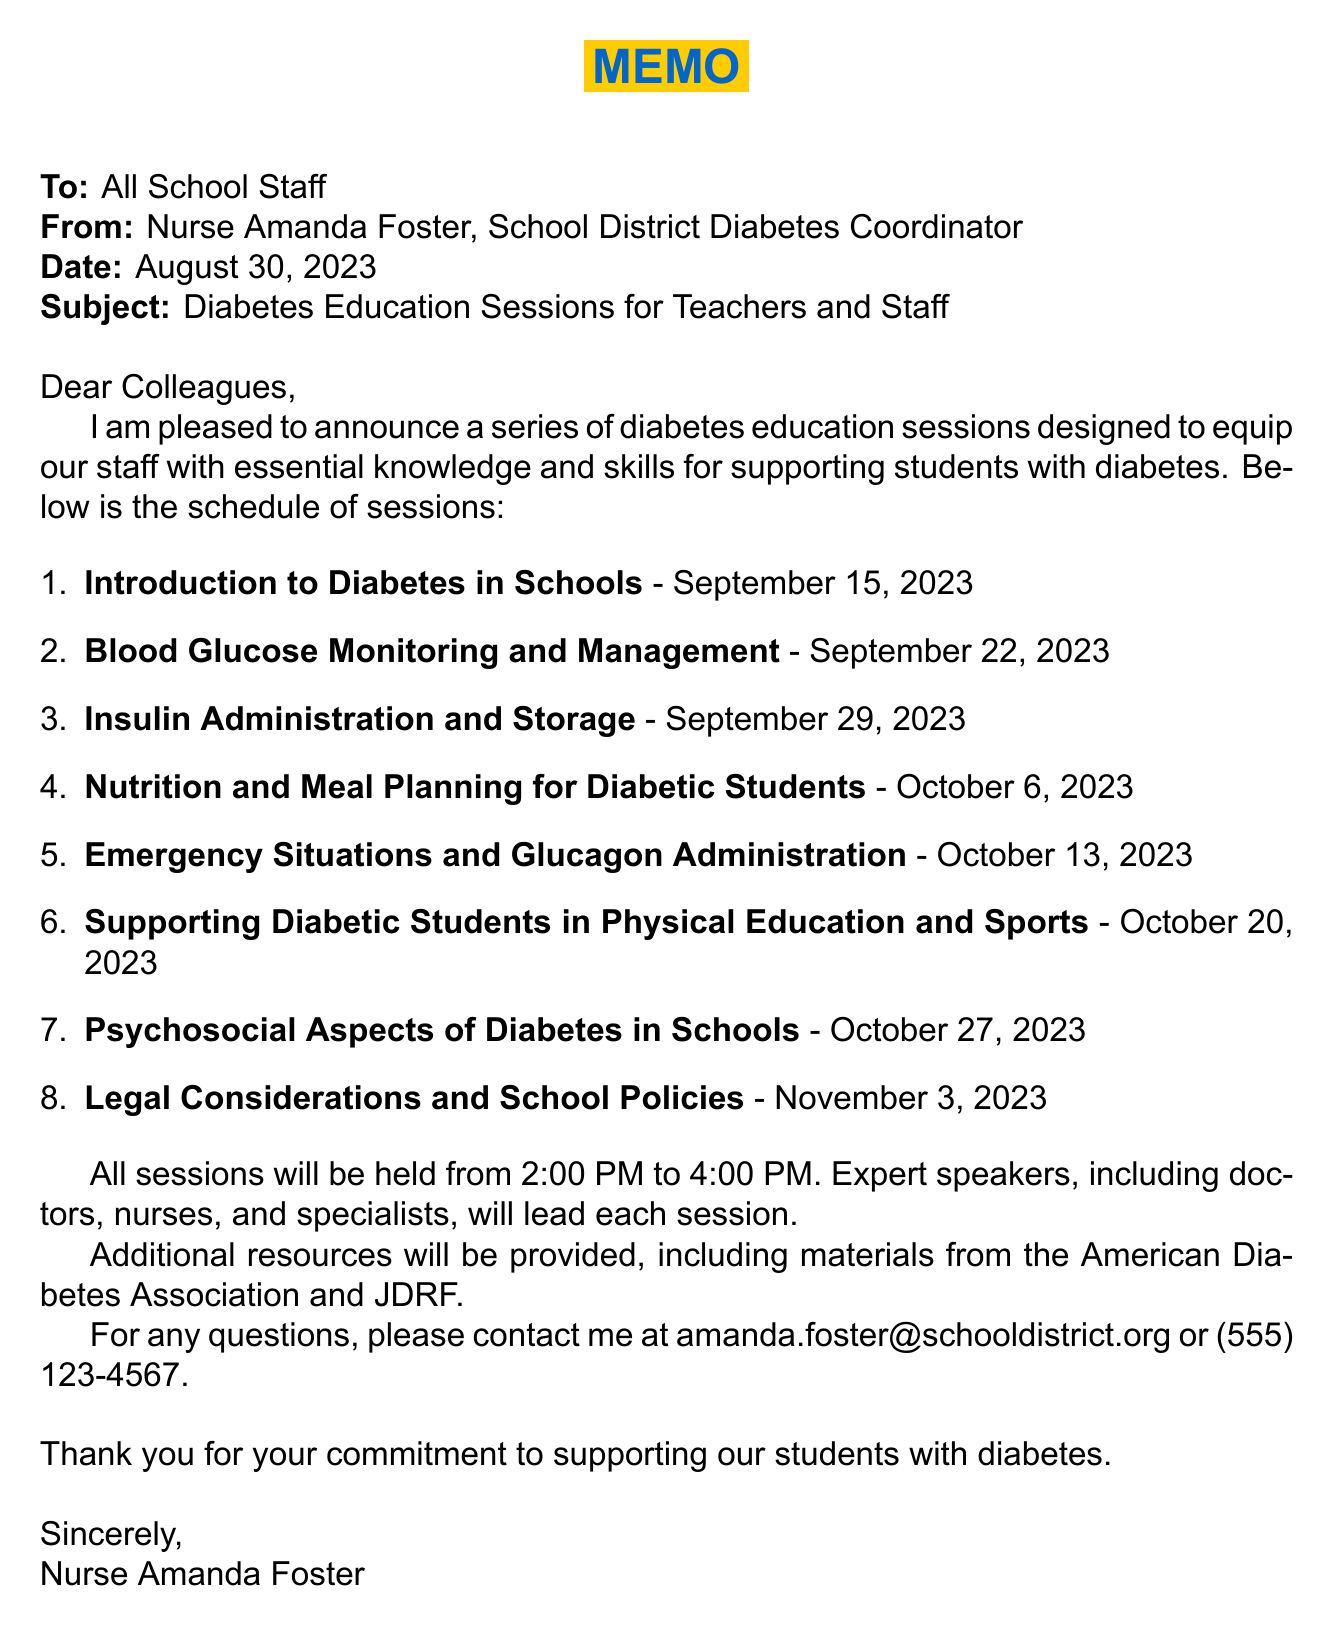What is the date of the first session? The first session is scheduled for September 15, 2023.
Answer: September 15, 2023 Who is the speaker for the session on nutrition? The nutrition session will be led by Emily Thompson, who is a Registered Dietitian.
Answer: Emily Thompson What is the time for the diabetes education sessions? All sessions are scheduled to take place from 2:00 PM to 4:00 PM.
Answer: 2:00 PM - 4:00 PM What is one topic covered in the session about emergency situations? The emergency situations session covers recognizing and responding to hypoglycemia.
Answer: Recognizing and responding to hypoglycemia How many sessions are proposed in total? There are a total of 8 proposed sessions listed in the schedule.
Answer: 8 What is the primary focus of the "Legal Considerations and School Policies" session? This session focuses on legal considerations such as the Americans with Disabilities Act and Section 504.
Answer: Americans with Disabilities Act and Section 504 Who coordinates the diabetes program in the school district? Nurse Amanda Foster is the School District Diabetes Coordinator.
Answer: Nurse Amanda Foster What is included in the additional resources provided? Additional resources include materials from the American Diabetes Association and JDRF.
Answer: American Diabetes Association and JDRF 